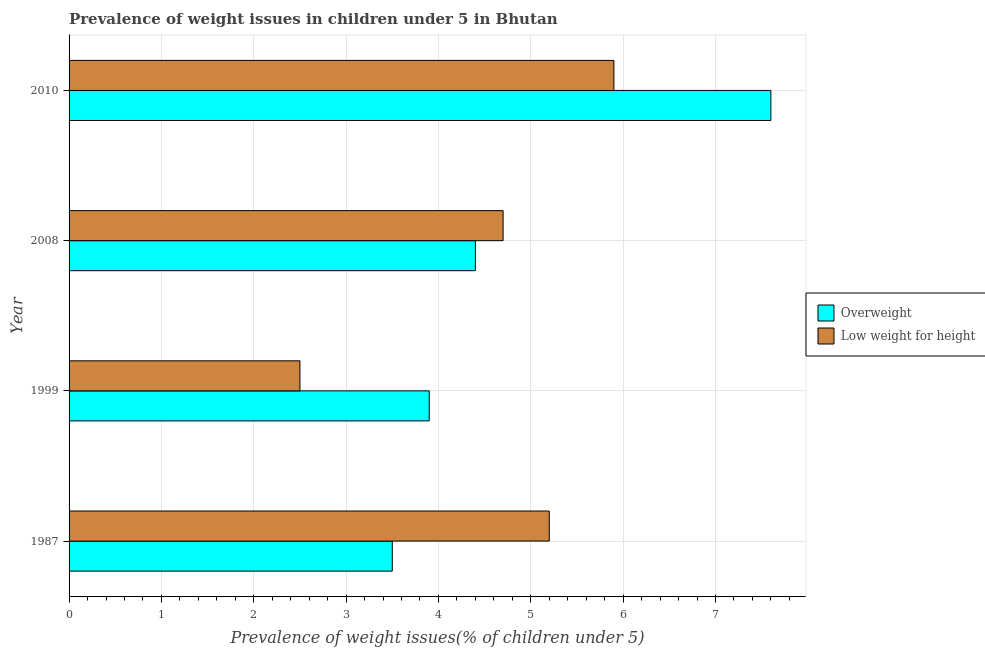How many different coloured bars are there?
Keep it short and to the point. 2. How many bars are there on the 1st tick from the bottom?
Offer a very short reply. 2. What is the label of the 3rd group of bars from the top?
Provide a short and direct response. 1999. What is the percentage of overweight children in 1999?
Ensure brevity in your answer.  3.9. Across all years, what is the maximum percentage of overweight children?
Make the answer very short. 7.6. What is the total percentage of overweight children in the graph?
Keep it short and to the point. 19.4. What is the difference between the percentage of underweight children in 1999 and the percentage of overweight children in 1987?
Provide a short and direct response. -1. What is the average percentage of overweight children per year?
Give a very brief answer. 4.85. What is the ratio of the percentage of overweight children in 1987 to that in 2008?
Offer a very short reply. 0.8. In how many years, is the percentage of underweight children greater than the average percentage of underweight children taken over all years?
Give a very brief answer. 3. Is the sum of the percentage of underweight children in 1987 and 2010 greater than the maximum percentage of overweight children across all years?
Your response must be concise. Yes. What does the 1st bar from the top in 1999 represents?
Make the answer very short. Low weight for height. What does the 2nd bar from the bottom in 2008 represents?
Offer a very short reply. Low weight for height. How many bars are there?
Offer a terse response. 8. Are all the bars in the graph horizontal?
Your answer should be compact. Yes. How many years are there in the graph?
Your answer should be compact. 4. Are the values on the major ticks of X-axis written in scientific E-notation?
Provide a short and direct response. No. Does the graph contain any zero values?
Ensure brevity in your answer.  No. Does the graph contain grids?
Keep it short and to the point. Yes. Where does the legend appear in the graph?
Keep it short and to the point. Center right. How are the legend labels stacked?
Ensure brevity in your answer.  Vertical. What is the title of the graph?
Provide a succinct answer. Prevalence of weight issues in children under 5 in Bhutan. What is the label or title of the X-axis?
Your answer should be compact. Prevalence of weight issues(% of children under 5). What is the label or title of the Y-axis?
Provide a short and direct response. Year. What is the Prevalence of weight issues(% of children under 5) of Low weight for height in 1987?
Your response must be concise. 5.2. What is the Prevalence of weight issues(% of children under 5) of Overweight in 1999?
Give a very brief answer. 3.9. What is the Prevalence of weight issues(% of children under 5) of Overweight in 2008?
Keep it short and to the point. 4.4. What is the Prevalence of weight issues(% of children under 5) in Low weight for height in 2008?
Your answer should be very brief. 4.7. What is the Prevalence of weight issues(% of children under 5) in Overweight in 2010?
Your response must be concise. 7.6. What is the Prevalence of weight issues(% of children under 5) in Low weight for height in 2010?
Your answer should be very brief. 5.9. Across all years, what is the maximum Prevalence of weight issues(% of children under 5) in Overweight?
Ensure brevity in your answer.  7.6. Across all years, what is the maximum Prevalence of weight issues(% of children under 5) of Low weight for height?
Offer a very short reply. 5.9. What is the total Prevalence of weight issues(% of children under 5) of Overweight in the graph?
Your answer should be very brief. 19.4. What is the difference between the Prevalence of weight issues(% of children under 5) of Overweight in 1987 and that in 1999?
Your answer should be very brief. -0.4. What is the difference between the Prevalence of weight issues(% of children under 5) of Overweight in 1999 and that in 2008?
Offer a terse response. -0.5. What is the difference between the Prevalence of weight issues(% of children under 5) in Low weight for height in 2008 and that in 2010?
Give a very brief answer. -1.2. What is the difference between the Prevalence of weight issues(% of children under 5) of Overweight in 1987 and the Prevalence of weight issues(% of children under 5) of Low weight for height in 1999?
Your answer should be compact. 1. What is the difference between the Prevalence of weight issues(% of children under 5) in Overweight in 1987 and the Prevalence of weight issues(% of children under 5) in Low weight for height in 2010?
Provide a succinct answer. -2.4. What is the difference between the Prevalence of weight issues(% of children under 5) of Overweight in 1999 and the Prevalence of weight issues(% of children under 5) of Low weight for height in 2010?
Make the answer very short. -2. What is the average Prevalence of weight issues(% of children under 5) of Overweight per year?
Your response must be concise. 4.85. What is the average Prevalence of weight issues(% of children under 5) of Low weight for height per year?
Offer a very short reply. 4.58. In the year 2008, what is the difference between the Prevalence of weight issues(% of children under 5) in Overweight and Prevalence of weight issues(% of children under 5) in Low weight for height?
Offer a terse response. -0.3. In the year 2010, what is the difference between the Prevalence of weight issues(% of children under 5) of Overweight and Prevalence of weight issues(% of children under 5) of Low weight for height?
Your response must be concise. 1.7. What is the ratio of the Prevalence of weight issues(% of children under 5) of Overweight in 1987 to that in 1999?
Make the answer very short. 0.9. What is the ratio of the Prevalence of weight issues(% of children under 5) of Low weight for height in 1987 to that in 1999?
Keep it short and to the point. 2.08. What is the ratio of the Prevalence of weight issues(% of children under 5) of Overweight in 1987 to that in 2008?
Give a very brief answer. 0.8. What is the ratio of the Prevalence of weight issues(% of children under 5) of Low weight for height in 1987 to that in 2008?
Ensure brevity in your answer.  1.11. What is the ratio of the Prevalence of weight issues(% of children under 5) in Overweight in 1987 to that in 2010?
Offer a very short reply. 0.46. What is the ratio of the Prevalence of weight issues(% of children under 5) of Low weight for height in 1987 to that in 2010?
Offer a very short reply. 0.88. What is the ratio of the Prevalence of weight issues(% of children under 5) in Overweight in 1999 to that in 2008?
Give a very brief answer. 0.89. What is the ratio of the Prevalence of weight issues(% of children under 5) of Low weight for height in 1999 to that in 2008?
Provide a short and direct response. 0.53. What is the ratio of the Prevalence of weight issues(% of children under 5) in Overweight in 1999 to that in 2010?
Your answer should be compact. 0.51. What is the ratio of the Prevalence of weight issues(% of children under 5) of Low weight for height in 1999 to that in 2010?
Provide a succinct answer. 0.42. What is the ratio of the Prevalence of weight issues(% of children under 5) of Overweight in 2008 to that in 2010?
Your response must be concise. 0.58. What is the ratio of the Prevalence of weight issues(% of children under 5) of Low weight for height in 2008 to that in 2010?
Provide a succinct answer. 0.8. What is the difference between the highest and the second highest Prevalence of weight issues(% of children under 5) of Overweight?
Give a very brief answer. 3.2. What is the difference between the highest and the lowest Prevalence of weight issues(% of children under 5) of Overweight?
Ensure brevity in your answer.  4.1. What is the difference between the highest and the lowest Prevalence of weight issues(% of children under 5) of Low weight for height?
Provide a succinct answer. 3.4. 